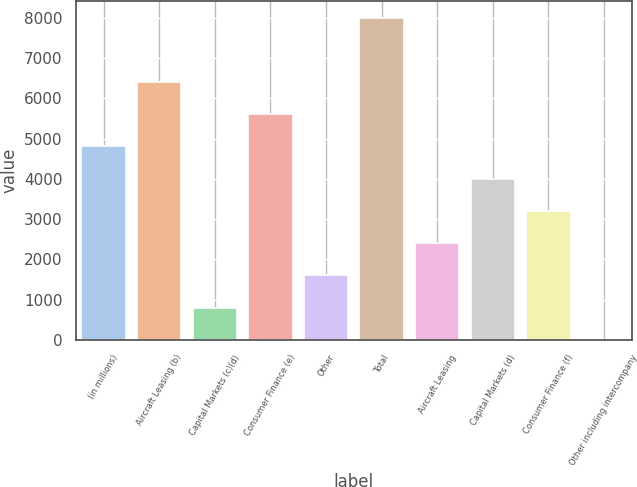Convert chart to OTSL. <chart><loc_0><loc_0><loc_500><loc_500><bar_chart><fcel>(in millions)<fcel>Aircraft Leasing (b)<fcel>Capital Markets (c)(d)<fcel>Consumer Finance (e)<fcel>Other<fcel>Total<fcel>Aircraft Leasing<fcel>Capital Markets (d)<fcel>Consumer Finance (f)<fcel>Other including intercompany<nl><fcel>4807.2<fcel>6408.6<fcel>803.7<fcel>5607.9<fcel>1604.4<fcel>8010<fcel>2405.1<fcel>4006.5<fcel>3205.8<fcel>3<nl></chart> 